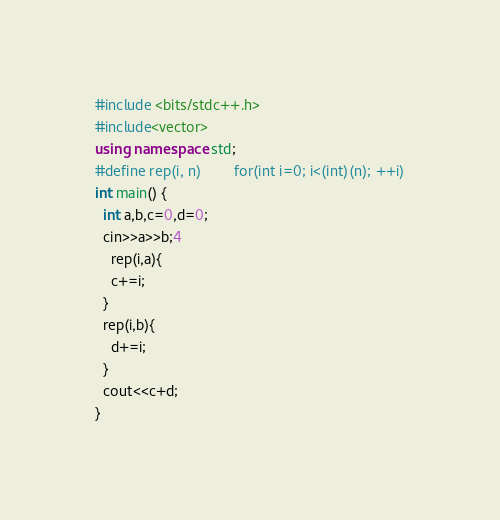<code> <loc_0><loc_0><loc_500><loc_500><_C++_>#include <bits/stdc++.h>
#include<vector>
using namespace std;
#define rep(i, n)        for(int i=0; i<(int)(n); ++i)
int main() {
  int a,b,c=0,d=0;
  cin>>a>>b;4
    rep(i,a){
    c+=i;
  } 
  rep(i,b){
    d+=i;
  }
  cout<<c+d;
}
</code> 